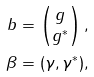Convert formula to latex. <formula><loc_0><loc_0><loc_500><loc_500>b & = \begin{pmatrix} g \\ g ^ { * } \end{pmatrix} , \\ \beta & = ( \gamma , \gamma ^ { * } ) ,</formula> 